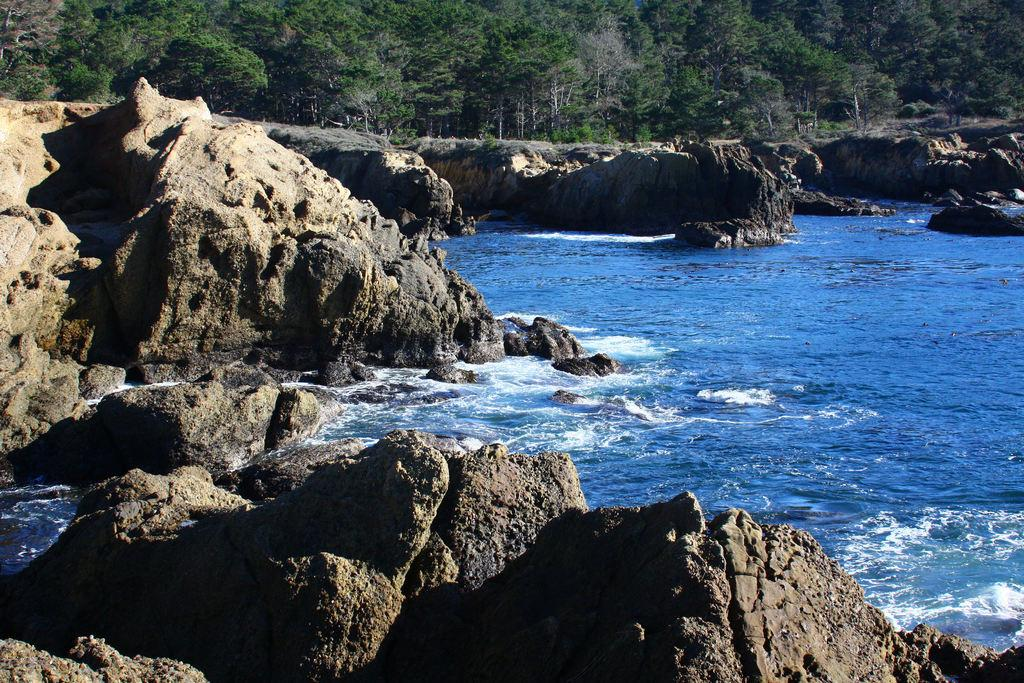What type of natural elements can be seen in the image? There are rocks and water visible in the image. What can be seen in the background of the image? There are trees in the background of the image. What type of salt can be seen on the rocks in the image? There is no salt visible on the rocks in the image. Which type of berry is growing on the trees in the background? There is no indication of berries growing on the trees in the image. 